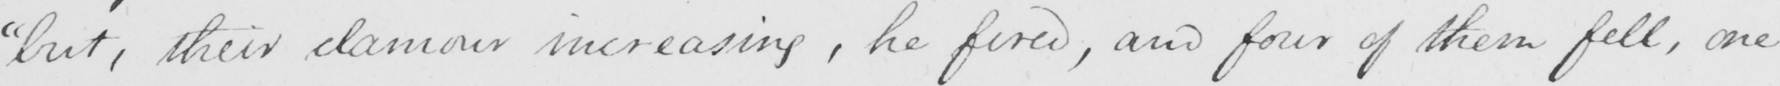What is written in this line of handwriting? " but , their clamour increasing , he fired , and four of them fell , one 